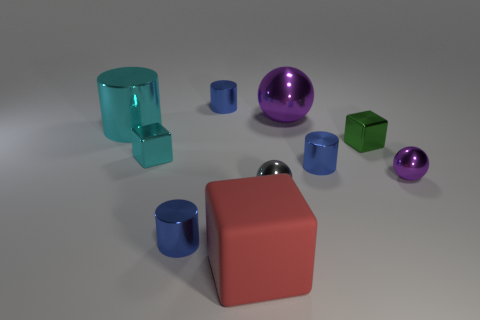What insights can you provide about the composition and layout of the objects in the image? The image's composition features an aesthetically pleasing arrangement of objects that play with symmetry and balance. The objects are thoughtfully spaced, suggesting an intention to depict diversity in shapes and transparency, while also allowing each object its moment of visual significance without cluttering the view. 